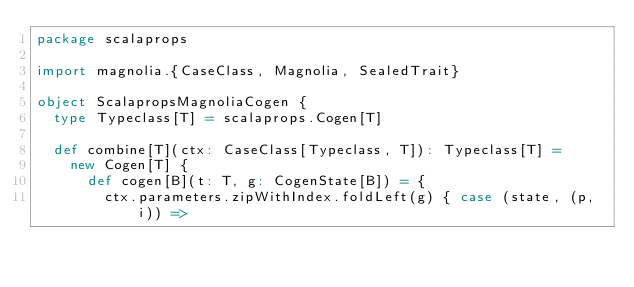<code> <loc_0><loc_0><loc_500><loc_500><_Scala_>package scalaprops

import magnolia.{CaseClass, Magnolia, SealedTrait}

object ScalapropsMagnoliaCogen {
  type Typeclass[T] = scalaprops.Cogen[T]

  def combine[T](ctx: CaseClass[Typeclass, T]): Typeclass[T] =
    new Cogen[T] {
      def cogen[B](t: T, g: CogenState[B]) = {
        ctx.parameters.zipWithIndex.foldLeft(g) { case (state, (p, i)) =></code> 